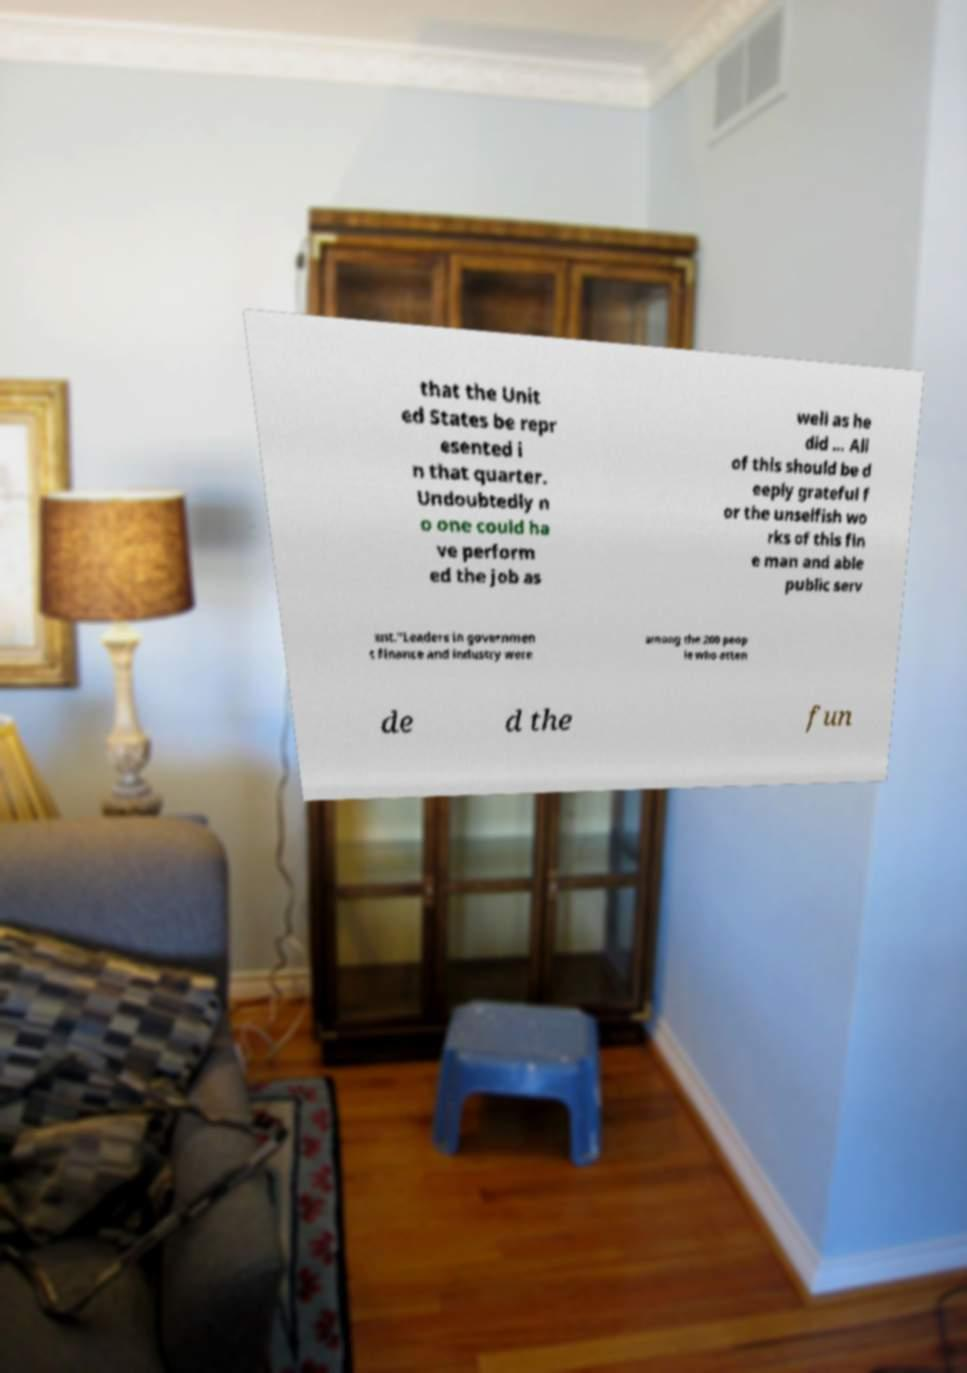Could you extract and type out the text from this image? that the Unit ed States be repr esented i n that quarter. Undoubtedly n o one could ha ve perform ed the job as well as he did ... All of this should be d eeply grateful f or the unselfish wo rks of this fin e man and able public serv ant."Leaders in governmen t finance and industry were among the 200 peop le who atten de d the fun 